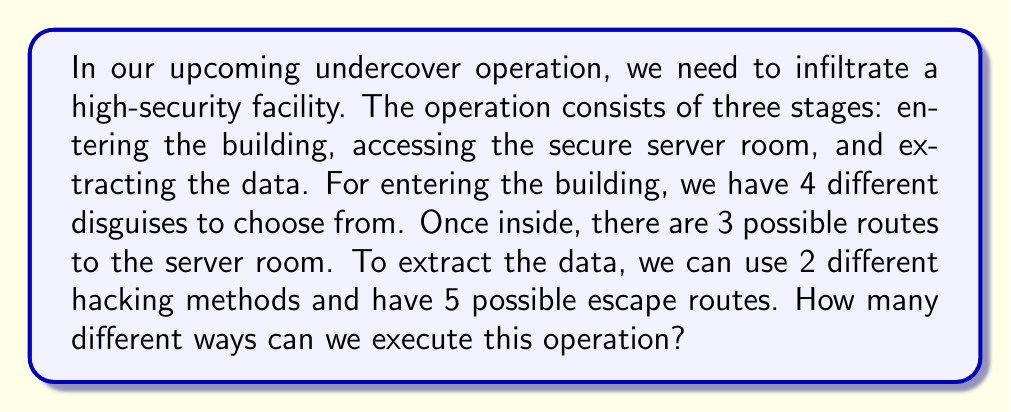Show me your answer to this math problem. Let's break down the problem and use the multiplication principle of counting:

1. Entering the building:
   We have 4 different disguises to choose from.

2. Accessing the server room:
   There are 3 possible routes to the server room.

3. Extracting the data:
   We have 2 different hacking methods and 5 possible escape routes.
   This gives us $2 \times 5 = 10$ combinations for data extraction.

Now, we apply the multiplication principle. The total number of ways to execute the operation is the product of the number of choices for each stage:

$$ \text{Total ways} = 4 \times 3 \times 10 $$

Calculating:
$$ \text{Total ways} = 4 \times 3 \times 10 = 120 $$

Therefore, there are 120 different ways to execute this undercover operation.
Answer: 120 